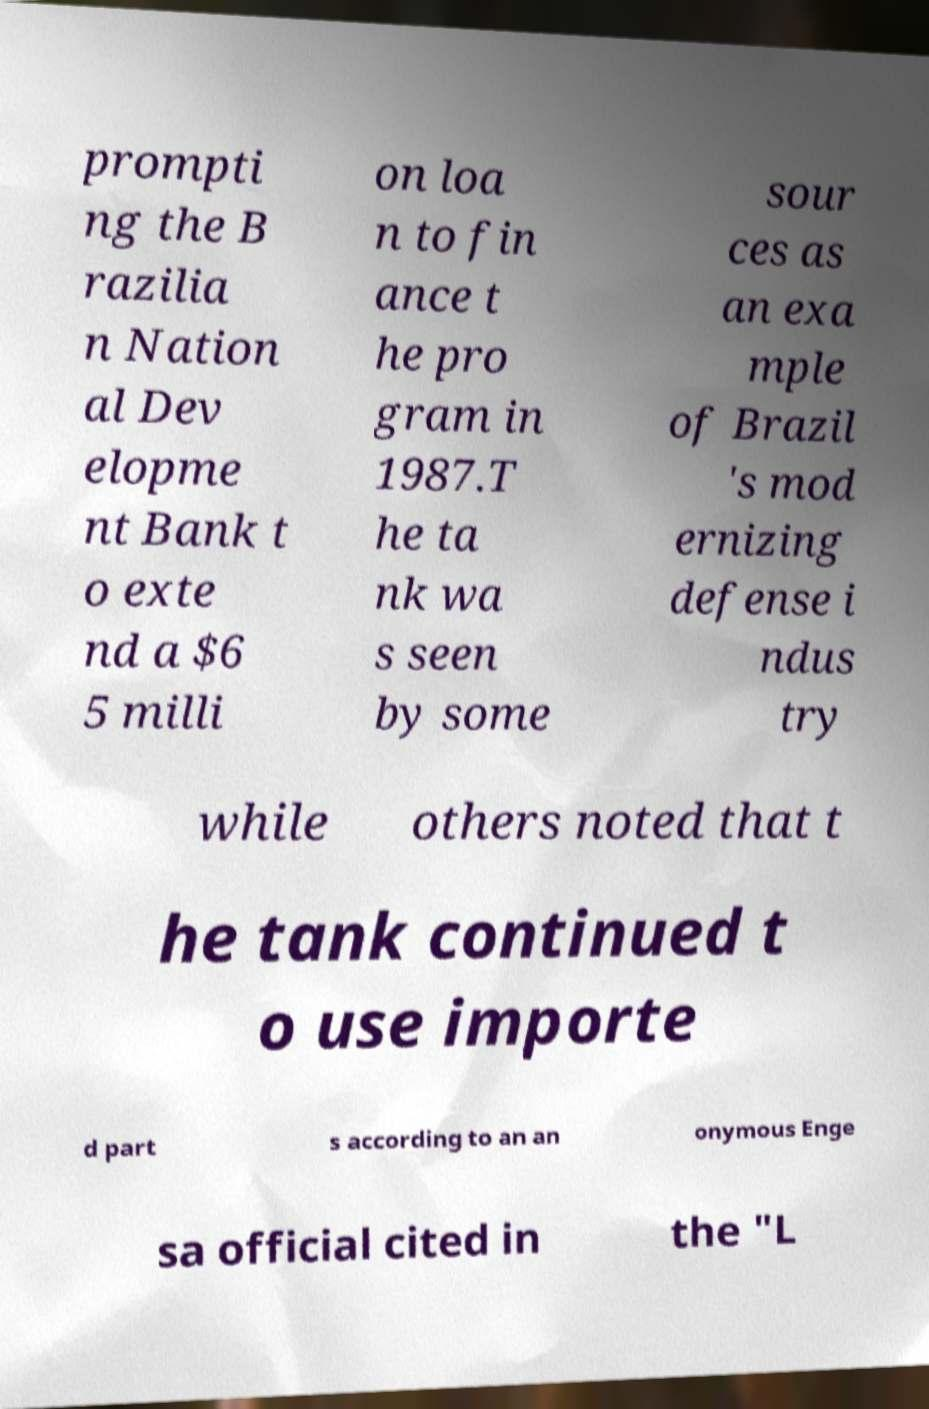There's text embedded in this image that I need extracted. Can you transcribe it verbatim? prompti ng the B razilia n Nation al Dev elopme nt Bank t o exte nd a $6 5 milli on loa n to fin ance t he pro gram in 1987.T he ta nk wa s seen by some sour ces as an exa mple of Brazil 's mod ernizing defense i ndus try while others noted that t he tank continued t o use importe d part s according to an an onymous Enge sa official cited in the "L 